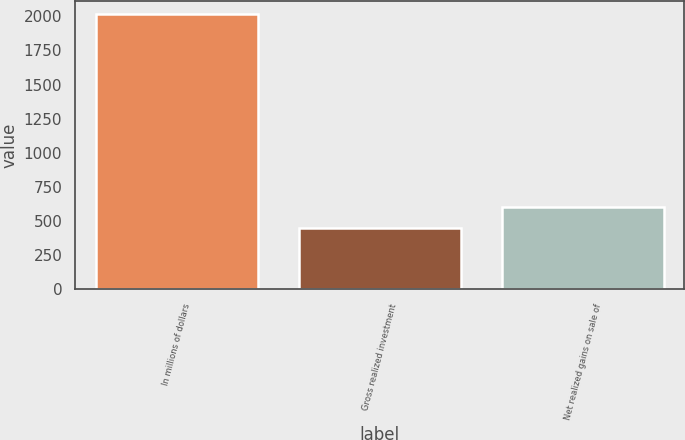Convert chart. <chart><loc_0><loc_0><loc_500><loc_500><bar_chart><fcel>In millions of dollars<fcel>Gross realized investment<fcel>Net realized gains on sale of<nl><fcel>2014<fcel>450<fcel>606.4<nl></chart> 